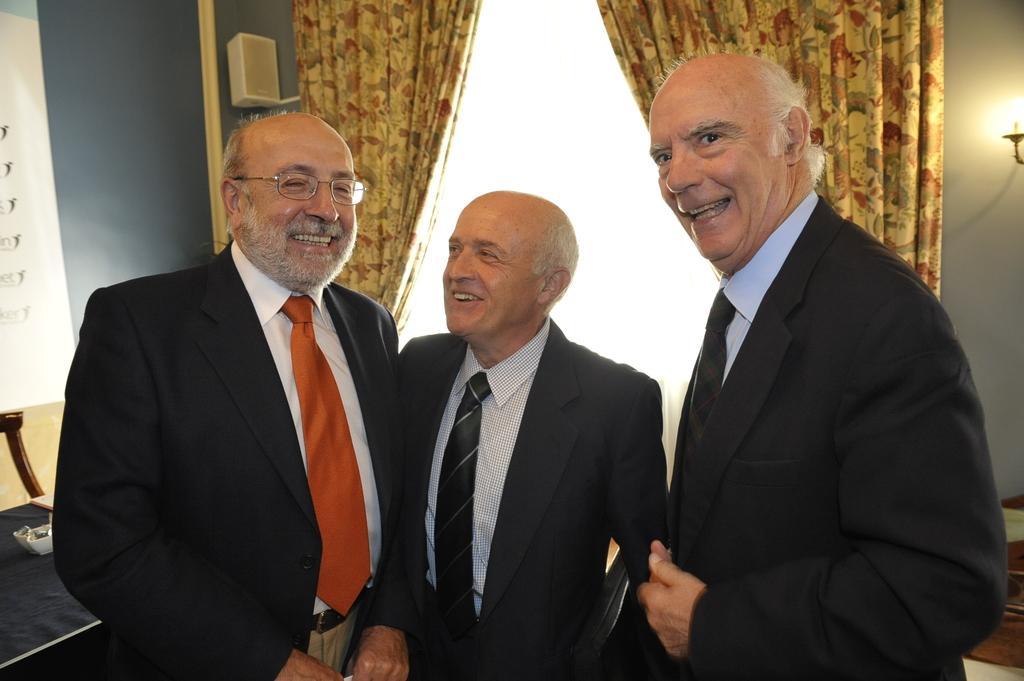How would you summarize this image in a sentence or two? In this picture I can see three persons standing and smiling, there are curtains, light, speaker and there are some other objects. 